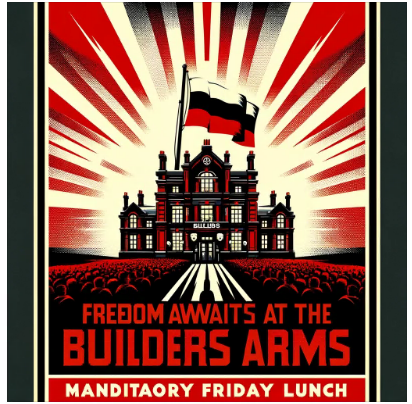how was this image created? This image was created using a variety of digital art techniques. The artist likely started by creating a sketch of the image on paper or in a digital drawing program. They then used a variety of digital tools to create the final image, including brushes, pens, and shapes. The artist also likely used a variety of filters and effects to create the desired look and feel of the image. 